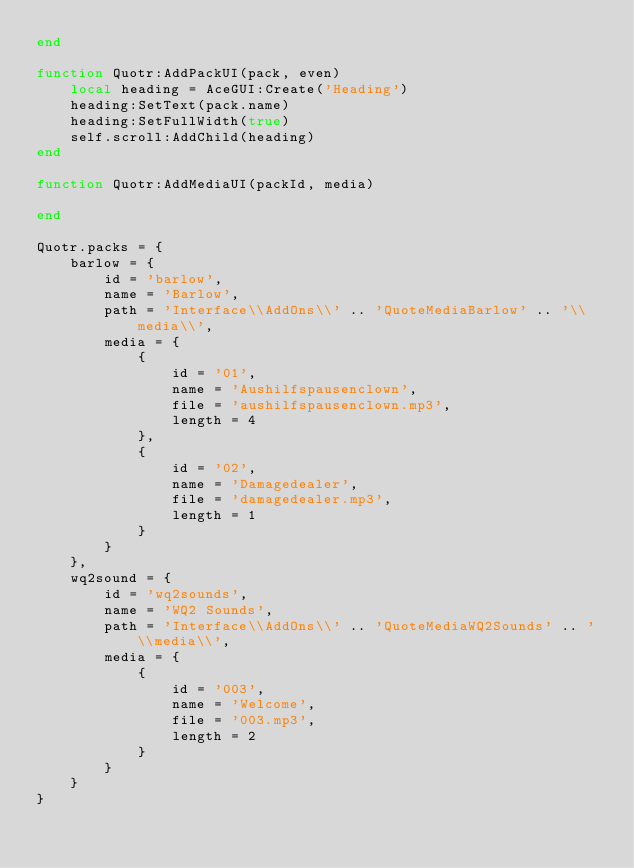<code> <loc_0><loc_0><loc_500><loc_500><_Lua_>end

function Quotr:AddPackUI(pack, even)
    local heading = AceGUI:Create('Heading')
    heading:SetText(pack.name)
    heading:SetFullWidth(true)
    self.scroll:AddChild(heading)
end

function Quotr:AddMediaUI(packId, media)

end

Quotr.packs = {
    barlow = {
        id = 'barlow',
        name = 'Barlow',
        path = 'Interface\\AddOns\\' .. 'QuoteMediaBarlow' .. '\\media\\',
        media = {
            {
                id = '01',
                name = 'Aushilfspausenclown',
                file = 'aushilfspausenclown.mp3',
                length = 4
            },
            {
                id = '02',
                name = 'Damagedealer',
                file = 'damagedealer.mp3',
                length = 1
            }
        }
    },
    wq2sound = {
        id = 'wq2sounds',
        name = 'WQ2 Sounds',
        path = 'Interface\\AddOns\\' .. 'QuoteMediaWQ2Sounds' .. '\\media\\',
        media = {
            {
                id = '003',
                name = 'Welcome',
                file = '003.mp3',
                length = 2
            }
        }
    }
}</code> 